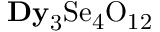Convert formula to latex. <formula><loc_0><loc_0><loc_500><loc_500>{ D y } _ { 3 } S e _ { 4 } O _ { 1 2 }</formula> 